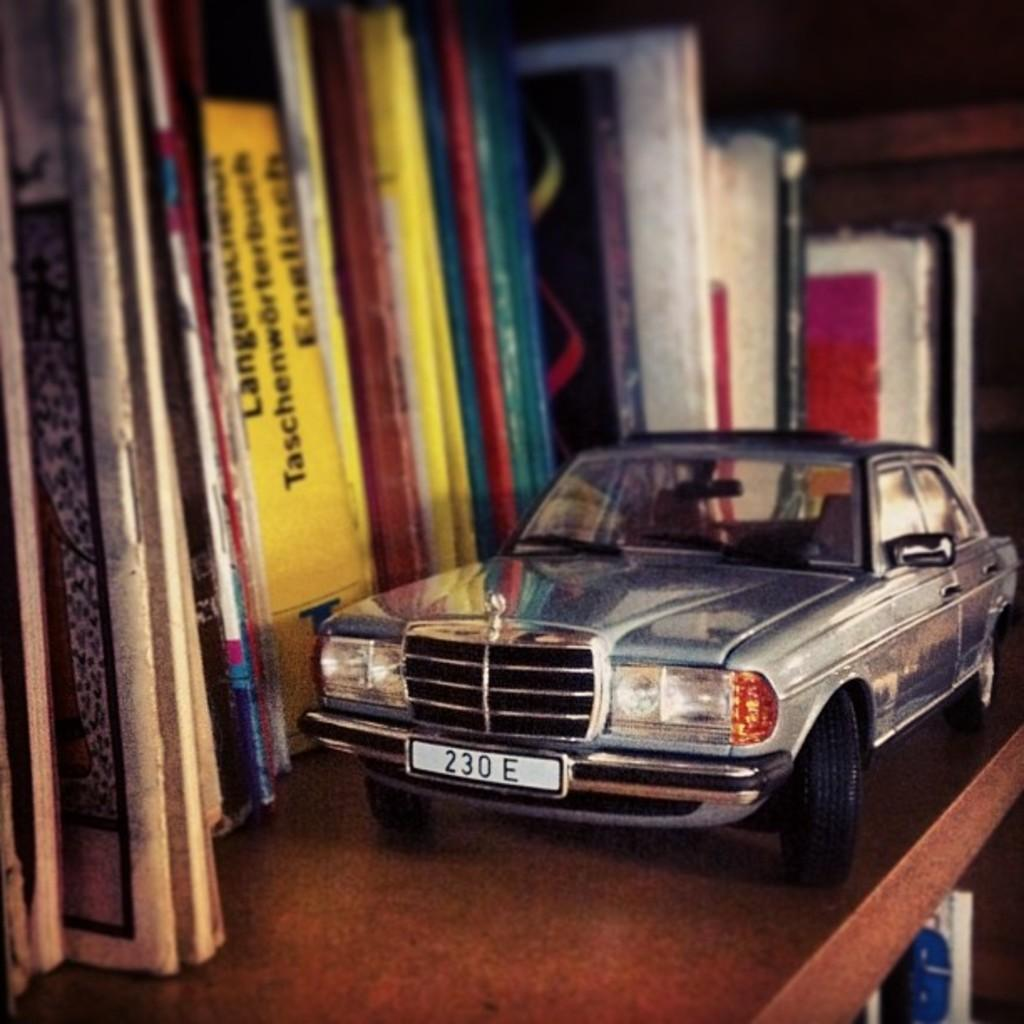What can be seen in the image? There is a shelf in the image. What is on the shelf? The shelf contains many books. Is there anything else in front of the books on the shelf? Yes, there is a small car in front of the books on the shelf. Where is the patch of grass located in the image? There is no patch of grass present in the image; it only features a shelf with books and a small car. Can you see a rabbit hopping around the books on the shelf? No, there is no rabbit present in the image. 